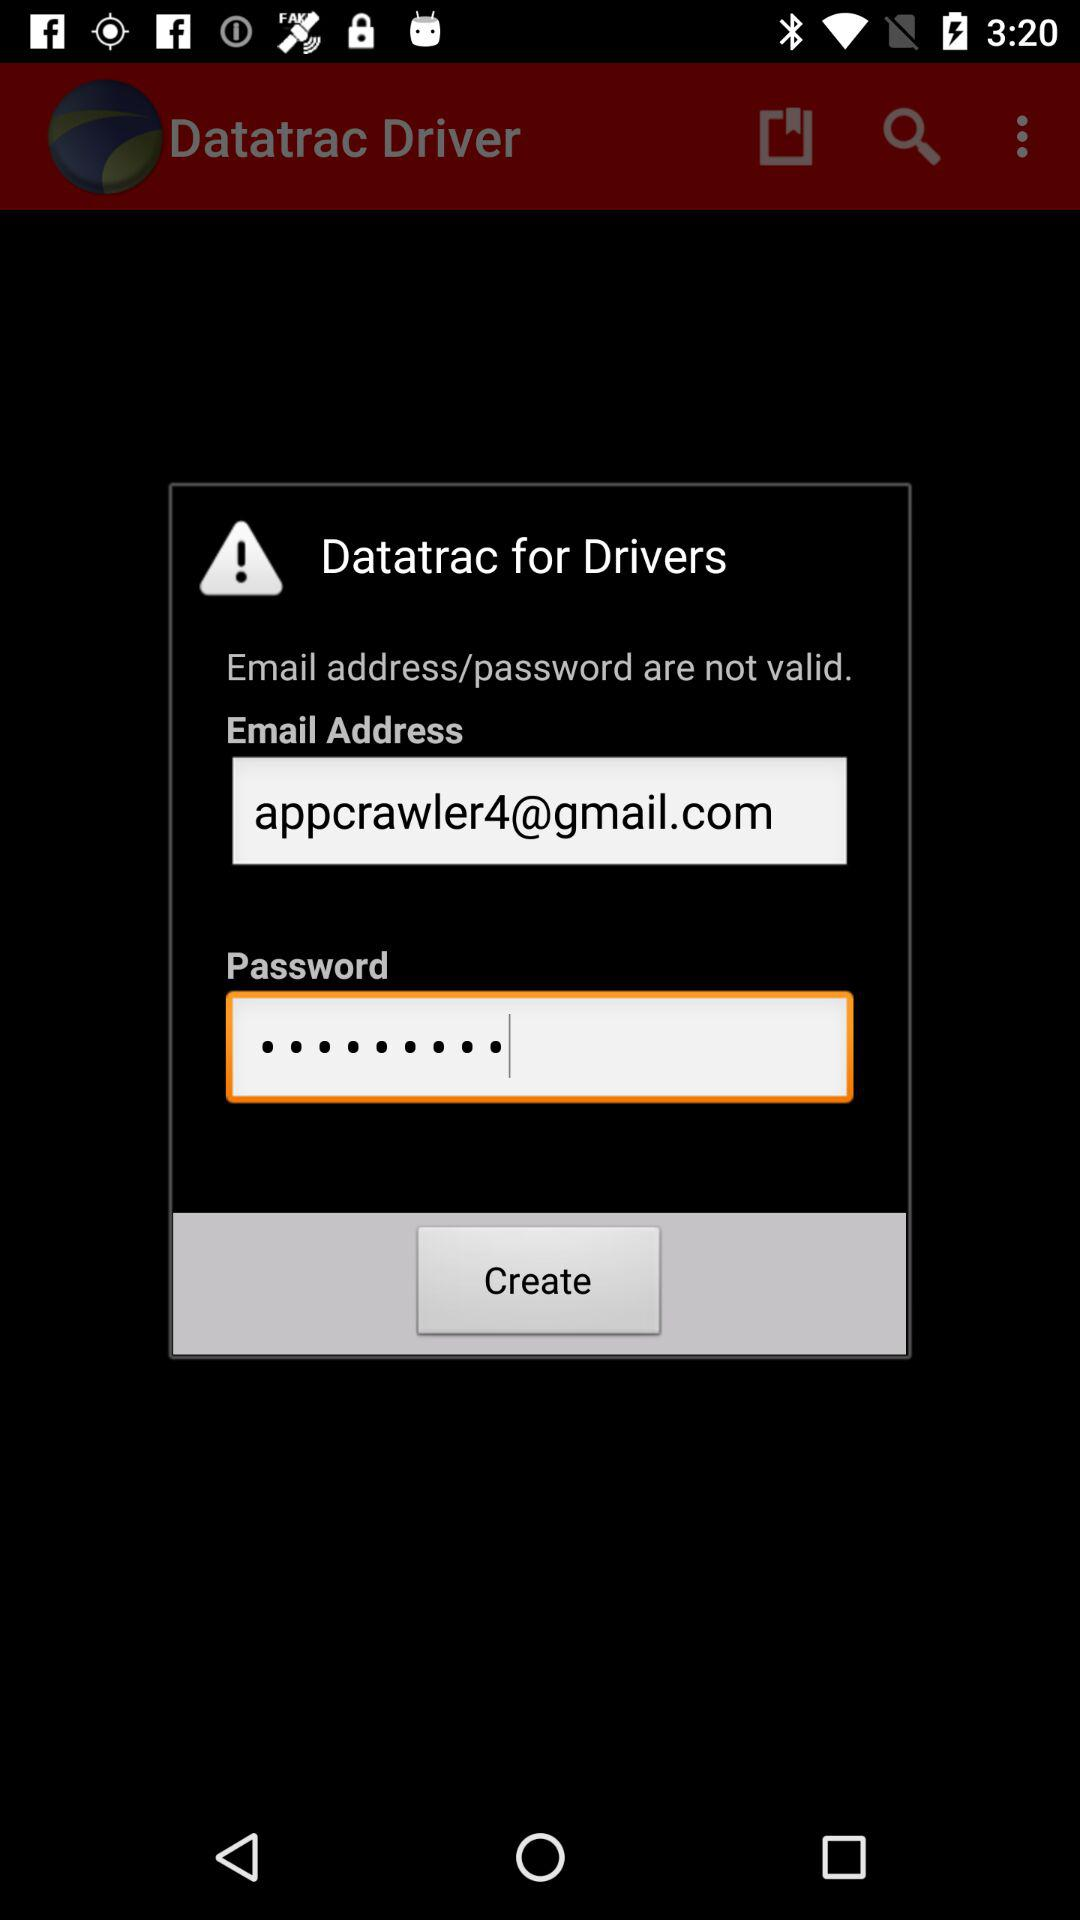What does the user drive?
When the provided information is insufficient, respond with <no answer>. <no answer> 